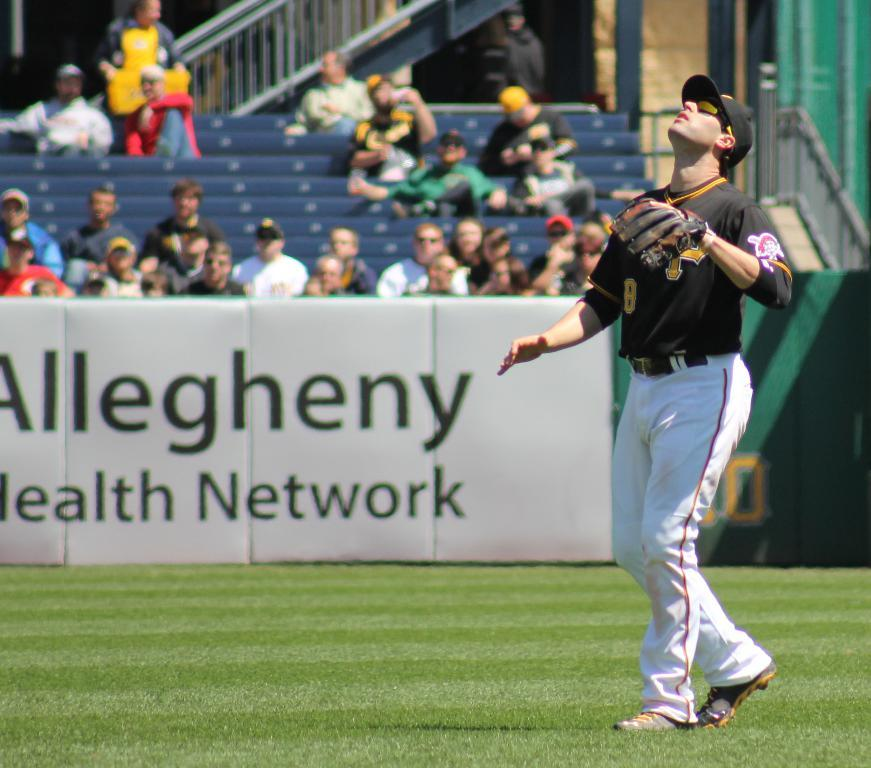<image>
Summarize the visual content of the image. A pirates baseball player looking up at a ball he is about to try to catch. 